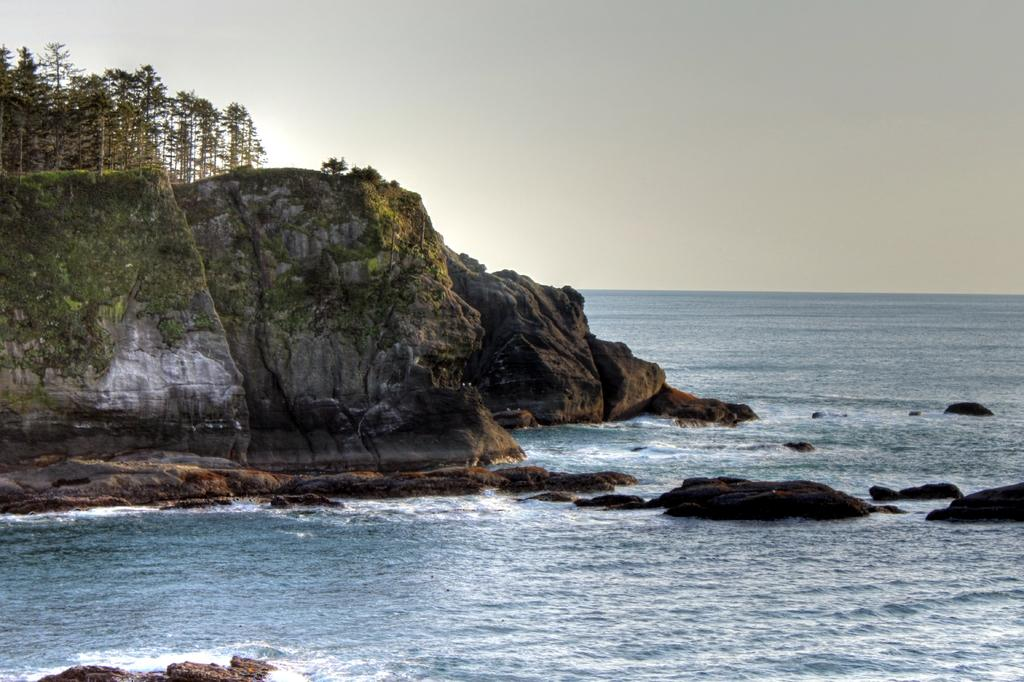What is the main geographical feature in the image? There is a mountain in the image. What can be seen on the mountain? There is a group of trees on the mountain. What is visible in the foreground of the image? There is water in the foreground of the image. What is visible in the background of the image? The sky is visible in the background of the image. How many eggs are being cooked in the mouth of the mountain in the image? There are no eggs or mouths present in the image; it features a mountain with trees and water in the foreground. 